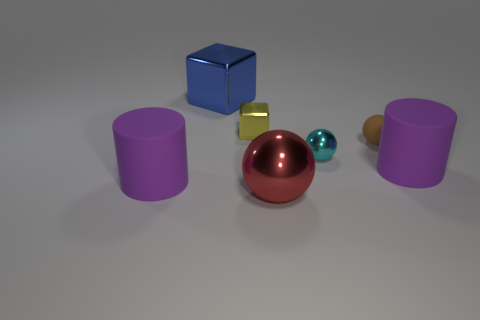Subtract all matte spheres. How many spheres are left? 2 Subtract all yellow cubes. How many cubes are left? 1 Add 3 big blue blocks. How many objects exist? 10 Subtract all blocks. How many objects are left? 5 Subtract 2 balls. How many balls are left? 1 Subtract 0 blue cylinders. How many objects are left? 7 Subtract all blue balls. Subtract all gray cylinders. How many balls are left? 3 Subtract all big yellow matte things. Subtract all small cyan metal balls. How many objects are left? 6 Add 6 red shiny balls. How many red shiny balls are left? 7 Add 2 yellow matte blocks. How many yellow matte blocks exist? 2 